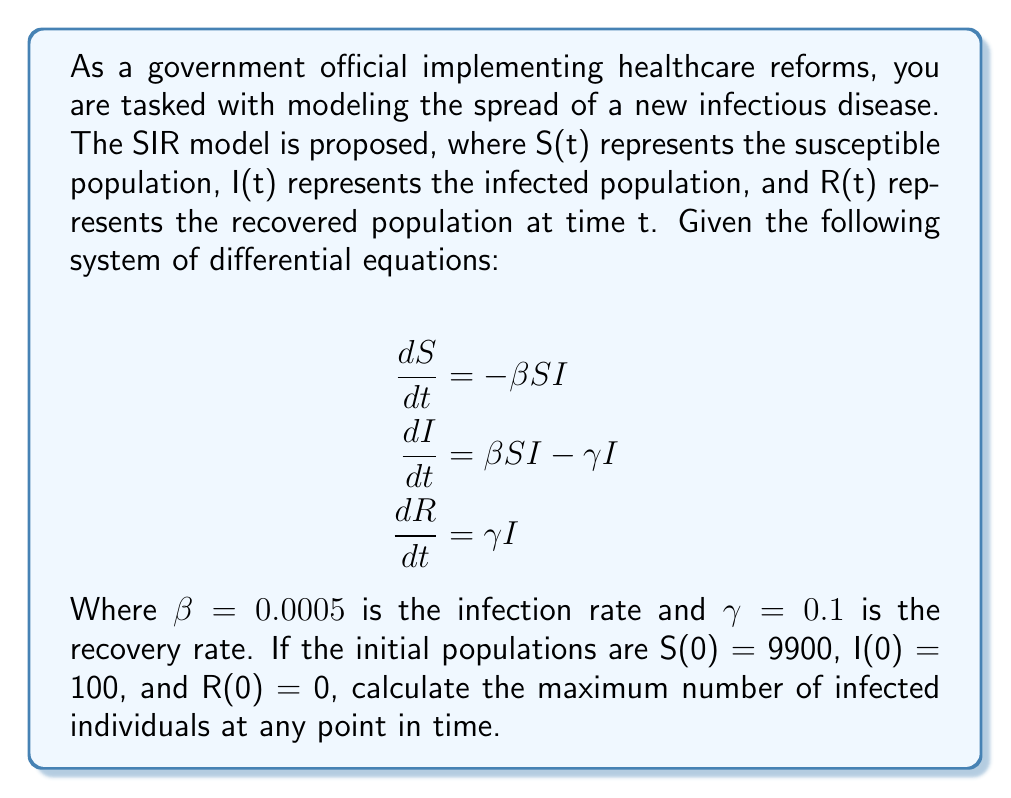Show me your answer to this math problem. To find the maximum number of infected individuals, we need to determine when dI/dt = 0, as this indicates the turning point where the infected population stops increasing and starts decreasing.

Step 1: Set dI/dt = 0
$$\frac{dI}{dt} = \beta SI - \gamma I = 0$$

Step 2: Solve for S
$$\beta SI - \gamma I = 0$$
$$\beta SI = \gamma I$$
$$S = \frac{\gamma}{\beta}$$

Step 3: Calculate S
$$S = \frac{0.1}{0.0005} = 200$$

Step 4: Use the conservation of population
$$N = S + I + R = 9900 + 100 + 0 = 10000$$

Step 5: Calculate I when S = 200
$$I = N - S - R = 10000 - 200 - R$$

Step 6: Calculate R using the equation for S
$$S = N - I - R$$
$$200 = 10000 - I - R$$
$$I + R = 9800$$

Step 7: Substitute I + R in the equation from Step 5
$$I = 10000 - 200 - (9800 - I)$$
$$I = 10000 - 200 - 9800 + I$$
$$0 = 0$$

This means I is at its maximum when S = 200.

Step 8: Calculate the maximum I
$$I_{max} = 10000 - 200 - R$$
$$I_{max} = 9800 - R$$

To find R, we use the fact that R(0) = 0 and integrate dR/dt from 0 to t:
$$R(t) = \int_0^t \gamma I(t) dt$$

Since we don't have an explicit function for I(t), we can approximate R when I is at its maximum:
$$R \approx \gamma \int_0^t I_{avg} dt \approx \gamma I_{avg} t$$

Assuming I_{avg} is about half of I_{max} and t is the time to reach the peak (roughly 1/γ):
$$R \approx 0.1 \cdot \frac{I_{max}}{2} \cdot \frac{1}{0.1} = \frac{I_{max}}{2}$$

Substituting this into the equation for I_{max}:
$$I_{max} = 9800 - \frac{I_{max}}{2}$$
$$\frac{3}{2}I_{max} = 9800$$
$$I_{max} = \frac{2}{3} \cdot 9800 \approx 6533$$
Answer: 6533 